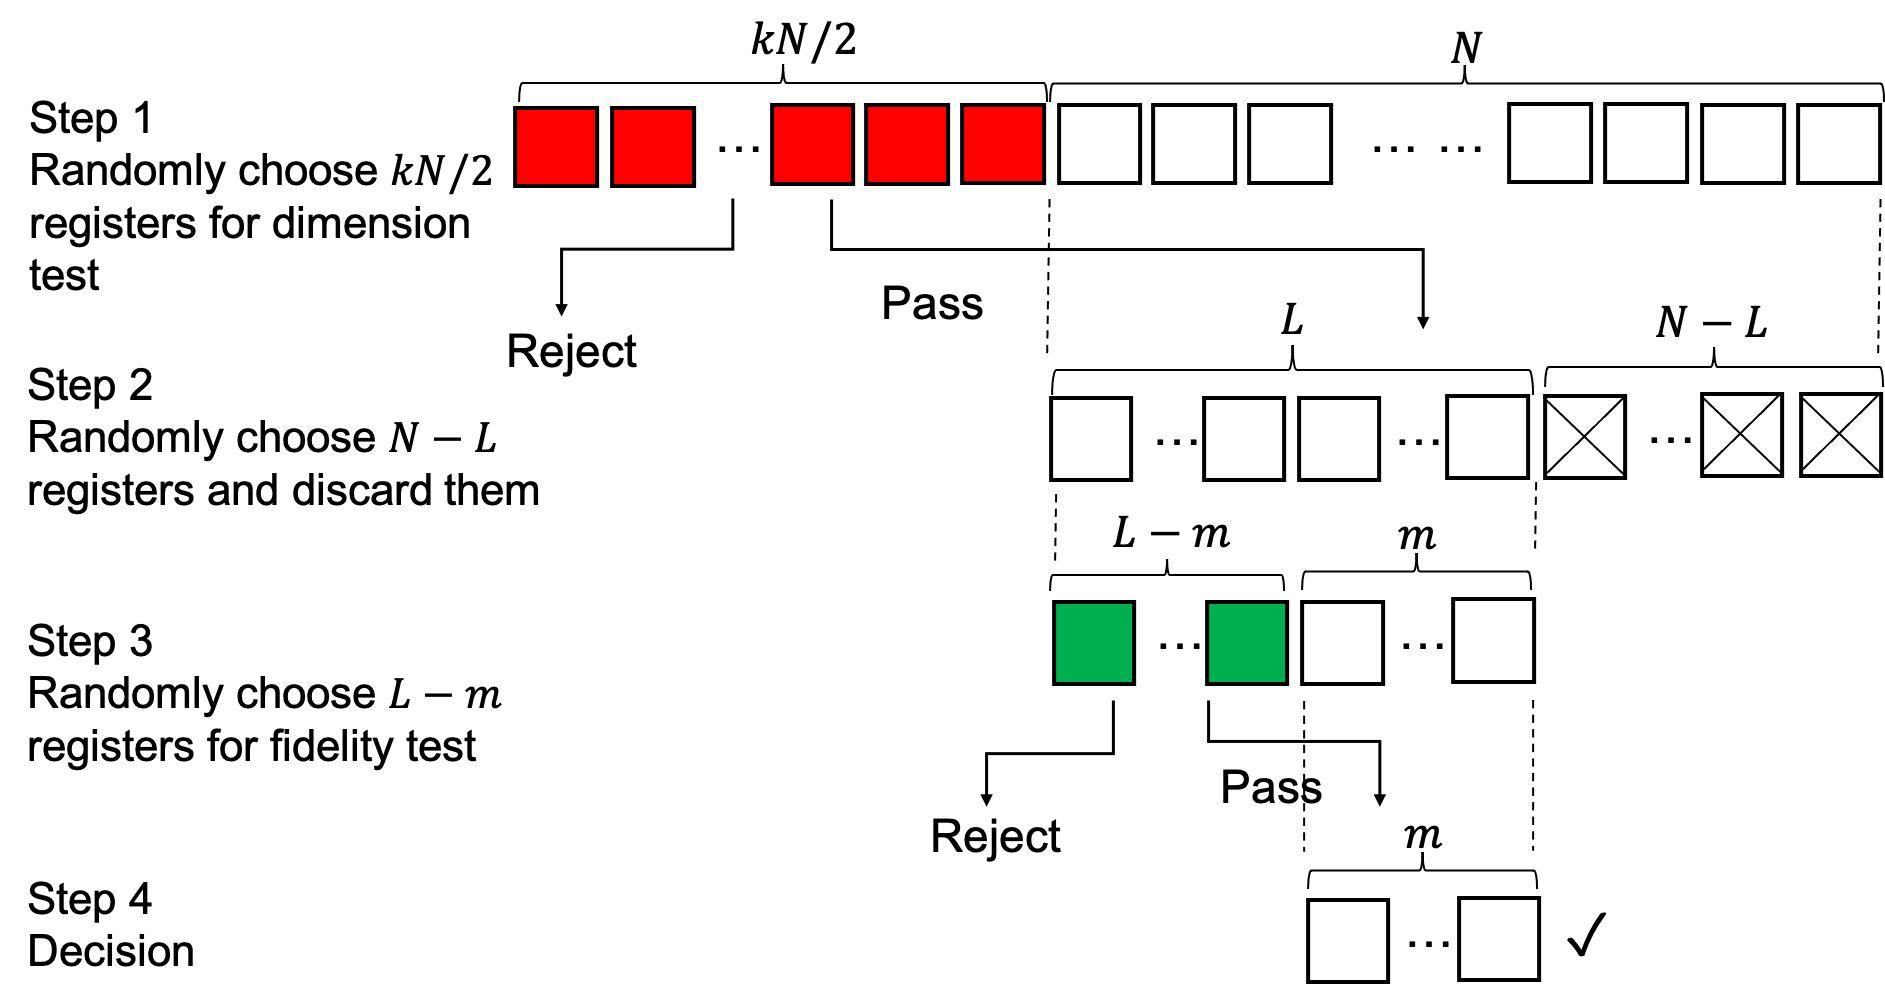What criteria might be used in the fidelity test shown in Step 3? While the image doesn't provide specific criteria for the fidelity test in Step 3, we can infer that it likely evaluates the remaining registers on a more nuanced or detailed level compared to the dimension test of Step 1. Fidelity tests usually assess how accurately or reliably a component performs its function. So in this context, the test might measure the consistency, precision, or stability of the registers under certain conditions or workload. Only those that pass this test can proceed to the final decision in Step 4. 